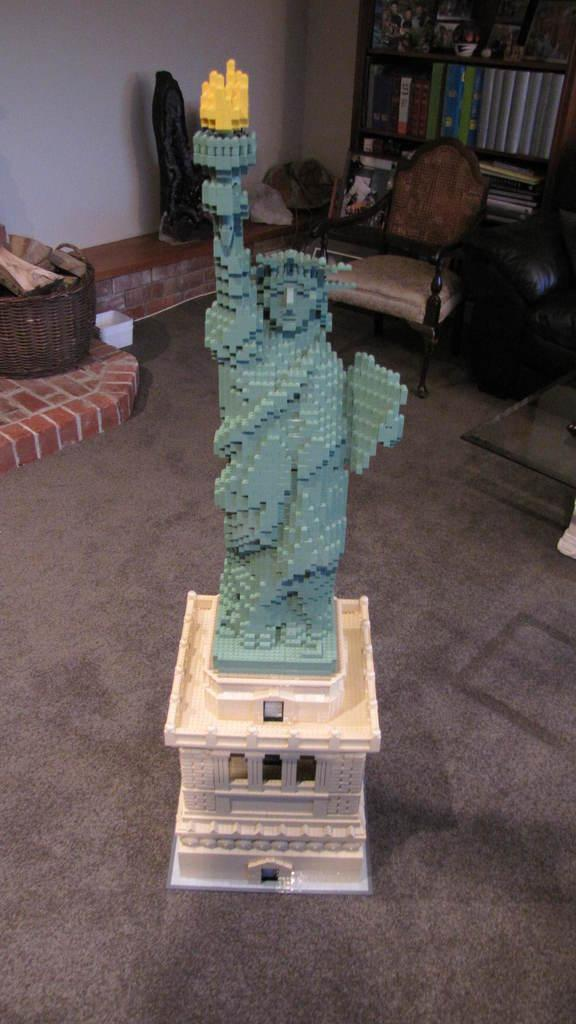What is the main object in the image? There is a statue in the image. What is on the floor in the image? There is a carpet on the floor in the image. What can be seen in the background of the image? In the background of the image, there is a basket, a chair, a sofa, a rack, books, and a wall. What type of education does the statue have in the image? The statue is an inanimate object and does not have any education. 